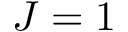<formula> <loc_0><loc_0><loc_500><loc_500>J = 1</formula> 